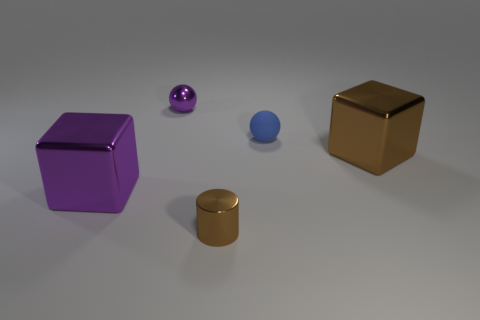What is the material of the small object in front of the metallic block that is on the right side of the tiny blue sphere?
Keep it short and to the point. Metal. How big is the shiny cylinder?
Ensure brevity in your answer.  Small. How many cylinders have the same size as the blue matte ball?
Offer a very short reply. 1. How many other small things are the same shape as the small brown object?
Give a very brief answer. 0. Are there an equal number of blue matte things to the left of the tiny brown metallic cylinder and small brown metallic objects?
Keep it short and to the point. No. Are there any other things that have the same size as the rubber sphere?
Provide a short and direct response. Yes. What is the shape of the brown object that is the same size as the blue rubber sphere?
Your answer should be very brief. Cylinder. Is there a small gray rubber thing that has the same shape as the tiny blue rubber thing?
Ensure brevity in your answer.  No. Is there a shiny sphere in front of the brown metal thing on the right side of the small shiny thing that is on the right side of the tiny purple metal object?
Offer a terse response. No. Are there more brown metal cylinders that are on the left side of the tiny purple object than tiny metal spheres in front of the cylinder?
Your answer should be very brief. No. 